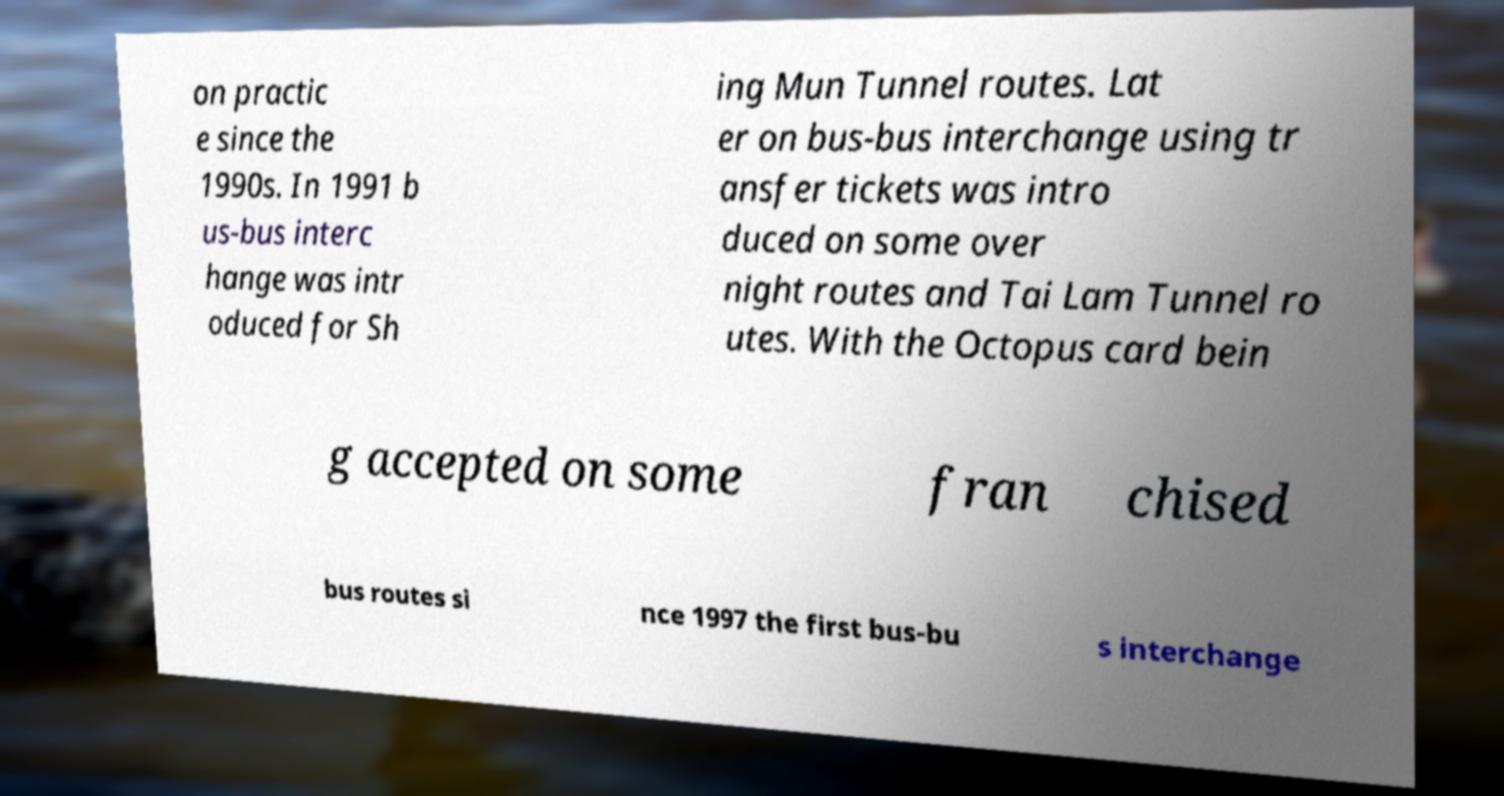Please read and relay the text visible in this image. What does it say? on practic e since the 1990s. In 1991 b us-bus interc hange was intr oduced for Sh ing Mun Tunnel routes. Lat er on bus-bus interchange using tr ansfer tickets was intro duced on some over night routes and Tai Lam Tunnel ro utes. With the Octopus card bein g accepted on some fran chised bus routes si nce 1997 the first bus-bu s interchange 